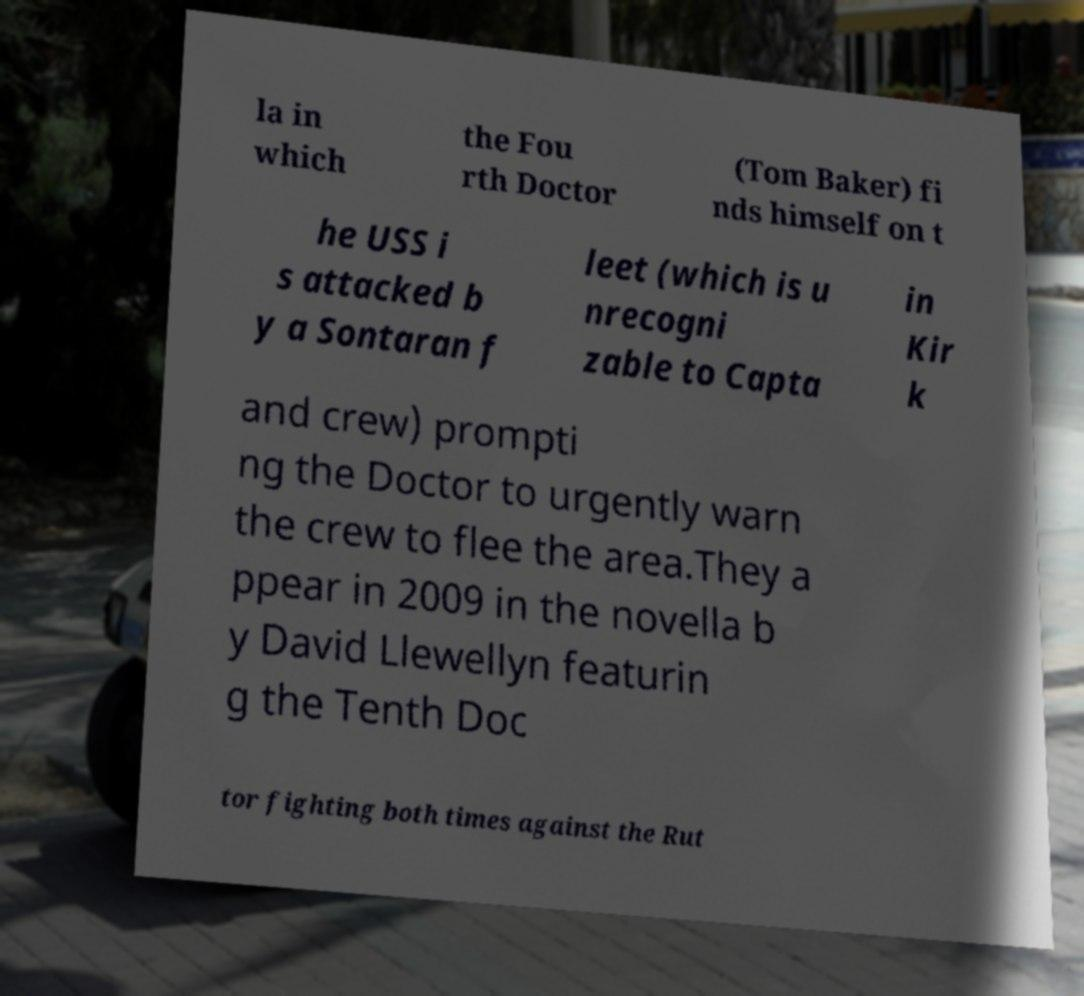Could you extract and type out the text from this image? la in which the Fou rth Doctor (Tom Baker) fi nds himself on t he USS i s attacked b y a Sontaran f leet (which is u nrecogni zable to Capta in Kir k and crew) prompti ng the Doctor to urgently warn the crew to flee the area.They a ppear in 2009 in the novella b y David Llewellyn featurin g the Tenth Doc tor fighting both times against the Rut 